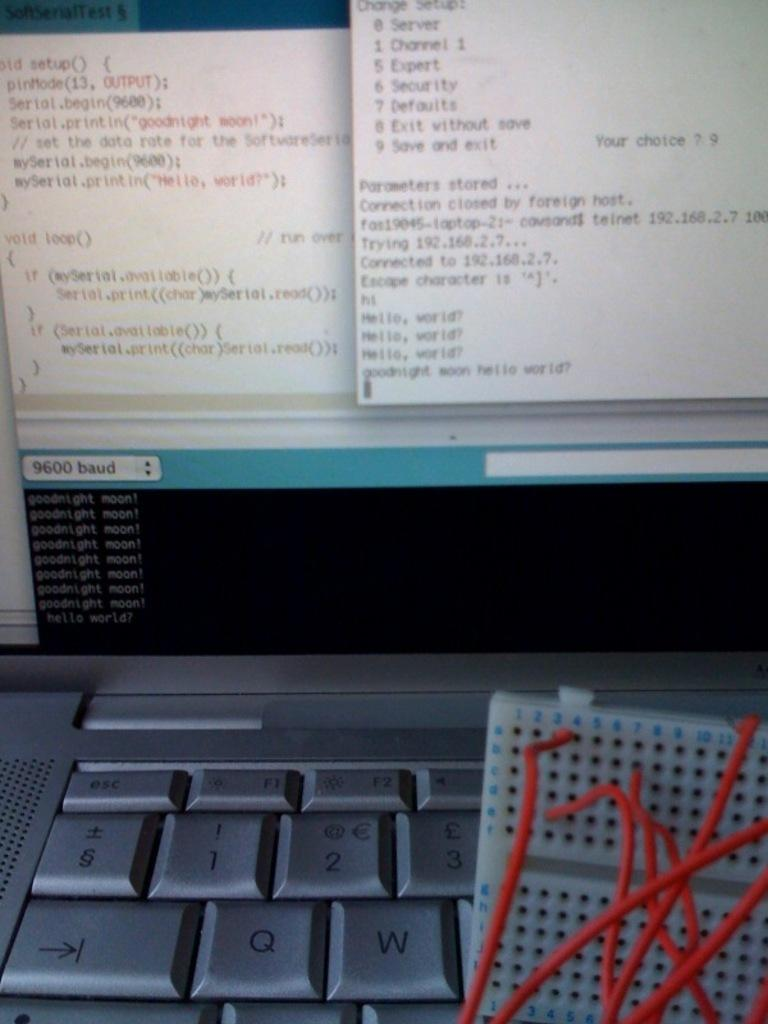<image>
Relay a brief, clear account of the picture shown. a computer that has 'goodnight moon!' on one of its open tabs over and over again 